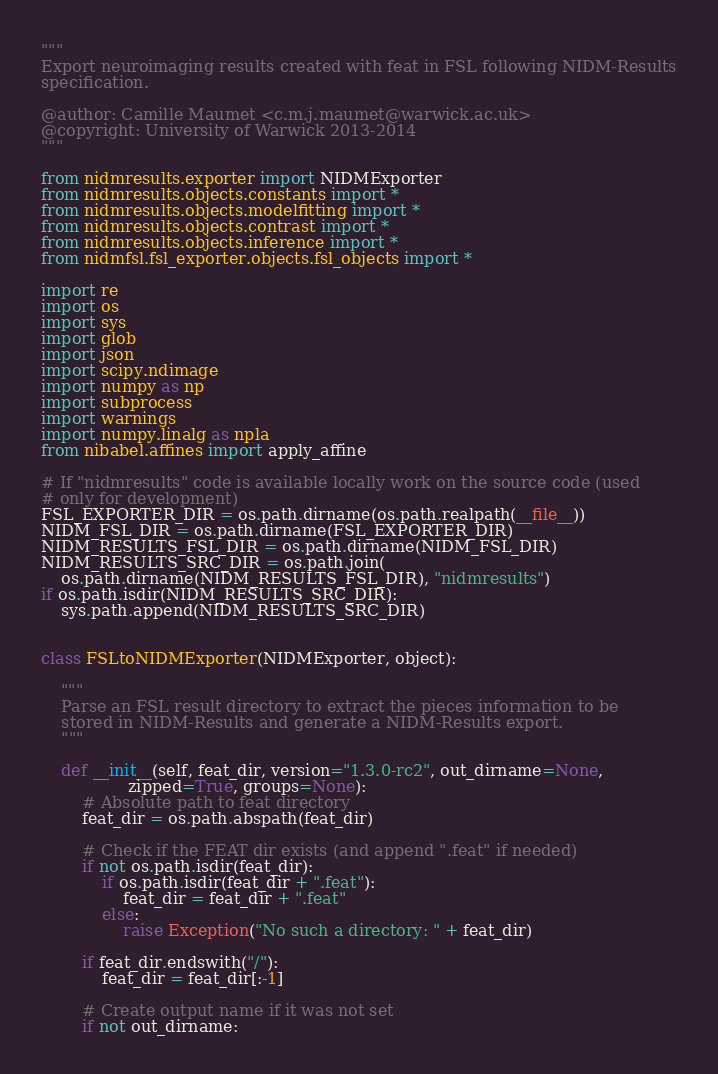<code> <loc_0><loc_0><loc_500><loc_500><_Python_>"""
Export neuroimaging results created with feat in FSL following NIDM-Results
specification.

@author: Camille Maumet <c.m.j.maumet@warwick.ac.uk>
@copyright: University of Warwick 2013-2014
"""

from nidmresults.exporter import NIDMExporter
from nidmresults.objects.constants import *
from nidmresults.objects.modelfitting import *
from nidmresults.objects.contrast import *
from nidmresults.objects.inference import *
from nidmfsl.fsl_exporter.objects.fsl_objects import *

import re
import os
import sys
import glob
import json
import scipy.ndimage
import numpy as np
import subprocess
import warnings
import numpy.linalg as npla
from nibabel.affines import apply_affine

# If "nidmresults" code is available locally work on the source code (used
# only for development)
FSL_EXPORTER_DIR = os.path.dirname(os.path.realpath(__file__))
NIDM_FSL_DIR = os.path.dirname(FSL_EXPORTER_DIR)
NIDM_RESULTS_FSL_DIR = os.path.dirname(NIDM_FSL_DIR)
NIDM_RESULTS_SRC_DIR = os.path.join(
    os.path.dirname(NIDM_RESULTS_FSL_DIR), "nidmresults")
if os.path.isdir(NIDM_RESULTS_SRC_DIR):
    sys.path.append(NIDM_RESULTS_SRC_DIR)


class FSLtoNIDMExporter(NIDMExporter, object):

    """
    Parse an FSL result directory to extract the pieces information to be
    stored in NIDM-Results and generate a NIDM-Results export.
    """

    def __init__(self, feat_dir, version="1.3.0-rc2", out_dirname=None,
                 zipped=True, groups=None):
        # Absolute path to feat directory
        feat_dir = os.path.abspath(feat_dir)

        # Check if the FEAT dir exists (and append ".feat" if needed)
        if not os.path.isdir(feat_dir):
            if os.path.isdir(feat_dir + ".feat"):
                feat_dir = feat_dir + ".feat"
            else:
                raise Exception("No such a directory: " + feat_dir)

        if feat_dir.endswith("/"):
            feat_dir = feat_dir[:-1]

        # Create output name if it was not set
        if not out_dirname:</code> 